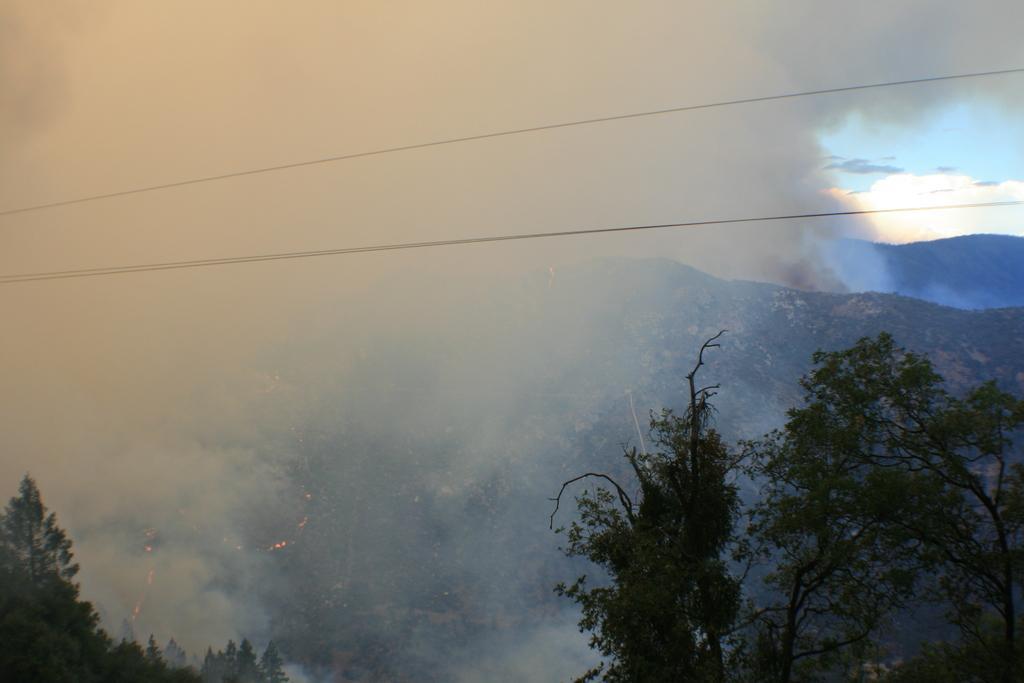Can you describe this image briefly? In this picture I can see few trees in front. In the middle of this smoke and the wires. In the background I see the mountains and the sky. 